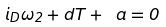<formula> <loc_0><loc_0><loc_500><loc_500>i _ { D } \omega _ { 2 } + d T + \ a = 0</formula> 